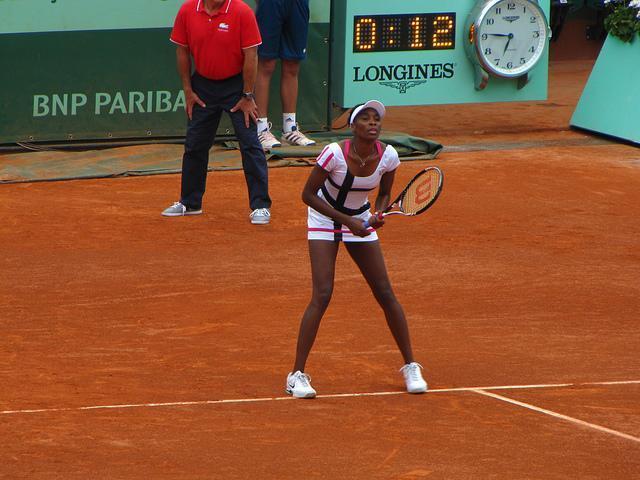How many people are there?
Give a very brief answer. 2. How many clocks are there?
Give a very brief answer. 2. 